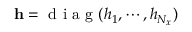<formula> <loc_0><loc_0><loc_500><loc_500>h = d i a g ( h _ { 1 } , \cdots , h _ { N _ { x } } )</formula> 